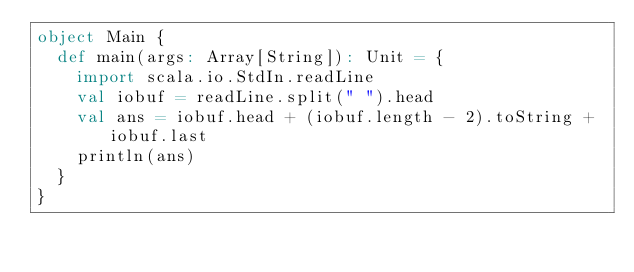Convert code to text. <code><loc_0><loc_0><loc_500><loc_500><_Scala_>object Main {
  def main(args: Array[String]): Unit = {
    import scala.io.StdIn.readLine
    val iobuf = readLine.split(" ").head
    val ans = iobuf.head + (iobuf.length - 2).toString + iobuf.last
    println(ans)
  }
}
</code> 